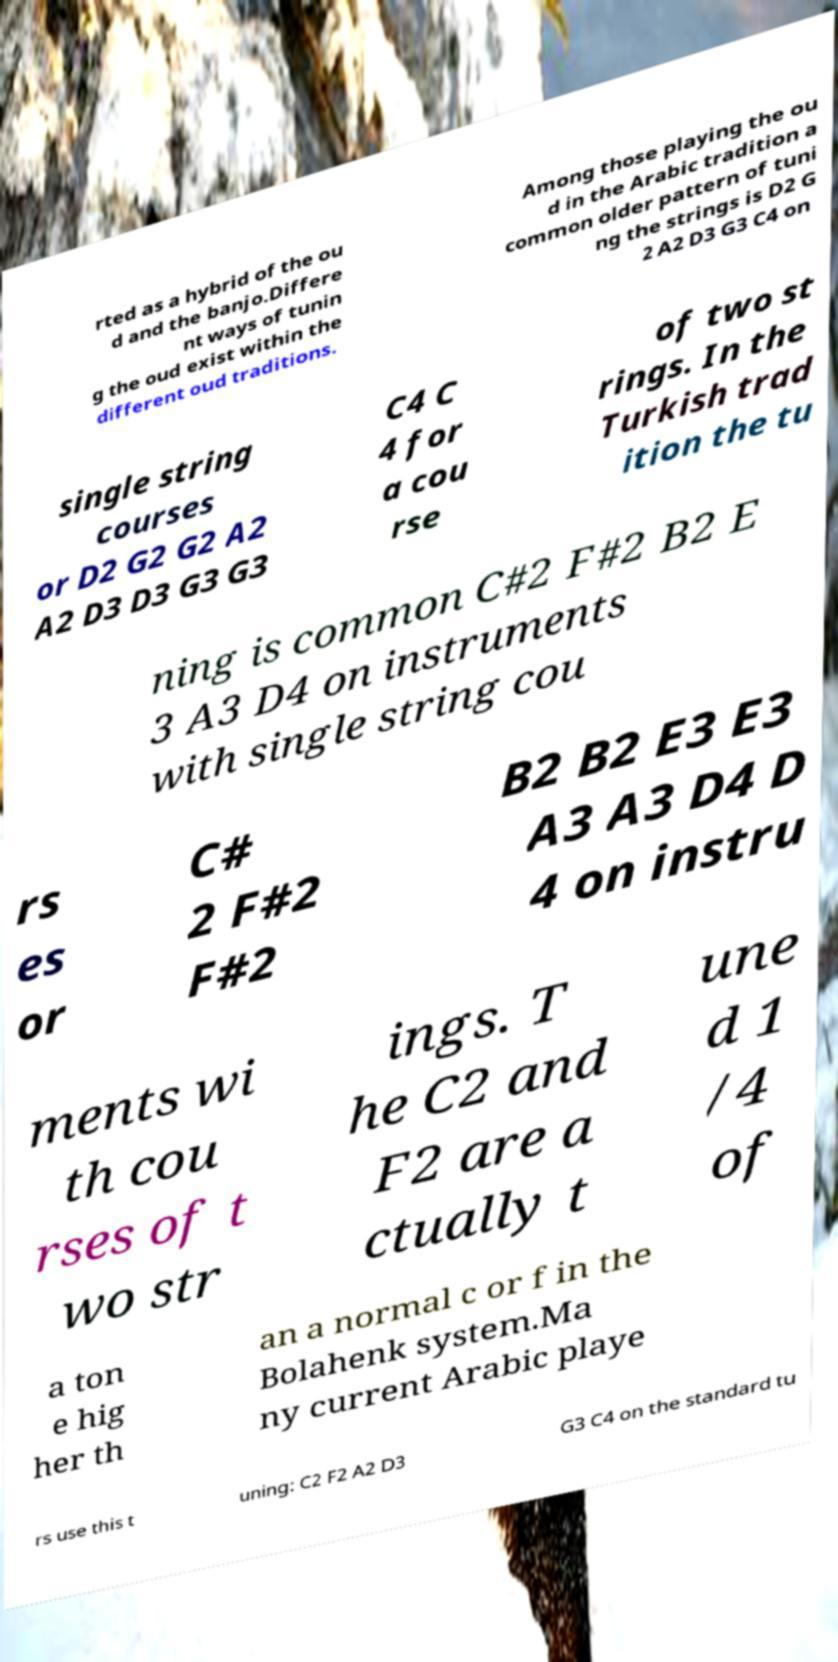I need the written content from this picture converted into text. Can you do that? rted as a hybrid of the ou d and the banjo.Differe nt ways of tunin g the oud exist within the different oud traditions. Among those playing the ou d in the Arabic tradition a common older pattern of tuni ng the strings is D2 G 2 A2 D3 G3 C4 on single string courses or D2 G2 G2 A2 A2 D3 D3 G3 G3 C4 C 4 for a cou rse of two st rings. In the Turkish trad ition the tu ning is common C#2 F#2 B2 E 3 A3 D4 on instruments with single string cou rs es or C# 2 F#2 F#2 B2 B2 E3 E3 A3 A3 D4 D 4 on instru ments wi th cou rses of t wo str ings. T he C2 and F2 are a ctually t une d 1 /4 of a ton e hig her th an a normal c or f in the Bolahenk system.Ma ny current Arabic playe rs use this t uning: C2 F2 A2 D3 G3 C4 on the standard tu 